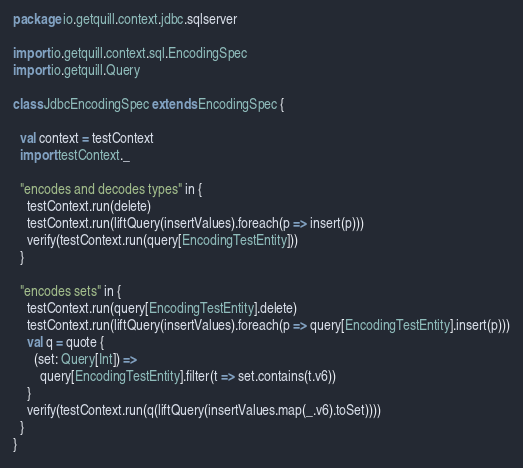Convert code to text. <code><loc_0><loc_0><loc_500><loc_500><_Scala_>package io.getquill.context.jdbc.sqlserver

import io.getquill.context.sql.EncodingSpec
import io.getquill.Query

class JdbcEncodingSpec extends EncodingSpec {

  val context = testContext
  import testContext._

  "encodes and decodes types" in {
    testContext.run(delete)
    testContext.run(liftQuery(insertValues).foreach(p => insert(p)))
    verify(testContext.run(query[EncodingTestEntity]))
  }

  "encodes sets" in {
    testContext.run(query[EncodingTestEntity].delete)
    testContext.run(liftQuery(insertValues).foreach(p => query[EncodingTestEntity].insert(p)))
    val q = quote {
      (set: Query[Int]) =>
        query[EncodingTestEntity].filter(t => set.contains(t.v6))
    }
    verify(testContext.run(q(liftQuery(insertValues.map(_.v6).toSet))))
  }
}</code> 